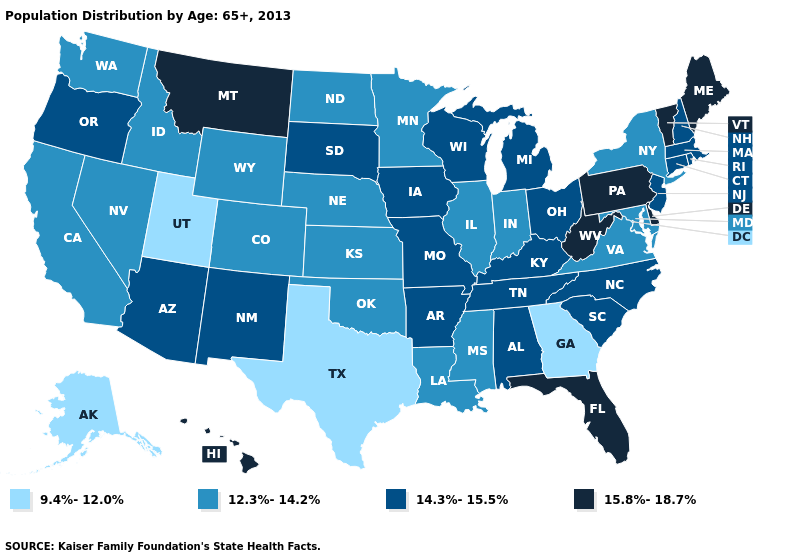What is the highest value in the West ?
Quick response, please. 15.8%-18.7%. Name the states that have a value in the range 15.8%-18.7%?
Keep it brief. Delaware, Florida, Hawaii, Maine, Montana, Pennsylvania, Vermont, West Virginia. Name the states that have a value in the range 14.3%-15.5%?
Answer briefly. Alabama, Arizona, Arkansas, Connecticut, Iowa, Kentucky, Massachusetts, Michigan, Missouri, New Hampshire, New Jersey, New Mexico, North Carolina, Ohio, Oregon, Rhode Island, South Carolina, South Dakota, Tennessee, Wisconsin. What is the value of Kansas?
Answer briefly. 12.3%-14.2%. Name the states that have a value in the range 15.8%-18.7%?
Concise answer only. Delaware, Florida, Hawaii, Maine, Montana, Pennsylvania, Vermont, West Virginia. Name the states that have a value in the range 12.3%-14.2%?
Quick response, please. California, Colorado, Idaho, Illinois, Indiana, Kansas, Louisiana, Maryland, Minnesota, Mississippi, Nebraska, Nevada, New York, North Dakota, Oklahoma, Virginia, Washington, Wyoming. What is the value of Delaware?
Answer briefly. 15.8%-18.7%. What is the value of Massachusetts?
Keep it brief. 14.3%-15.5%. Which states hav the highest value in the West?
Keep it brief. Hawaii, Montana. Which states have the highest value in the USA?
Answer briefly. Delaware, Florida, Hawaii, Maine, Montana, Pennsylvania, Vermont, West Virginia. What is the value of Utah?
Concise answer only. 9.4%-12.0%. Which states have the highest value in the USA?
Short answer required. Delaware, Florida, Hawaii, Maine, Montana, Pennsylvania, Vermont, West Virginia. Which states hav the highest value in the MidWest?
Write a very short answer. Iowa, Michigan, Missouri, Ohio, South Dakota, Wisconsin. Does New York have the lowest value in the Northeast?
Keep it brief. Yes. Does Florida have the lowest value in the South?
Answer briefly. No. 